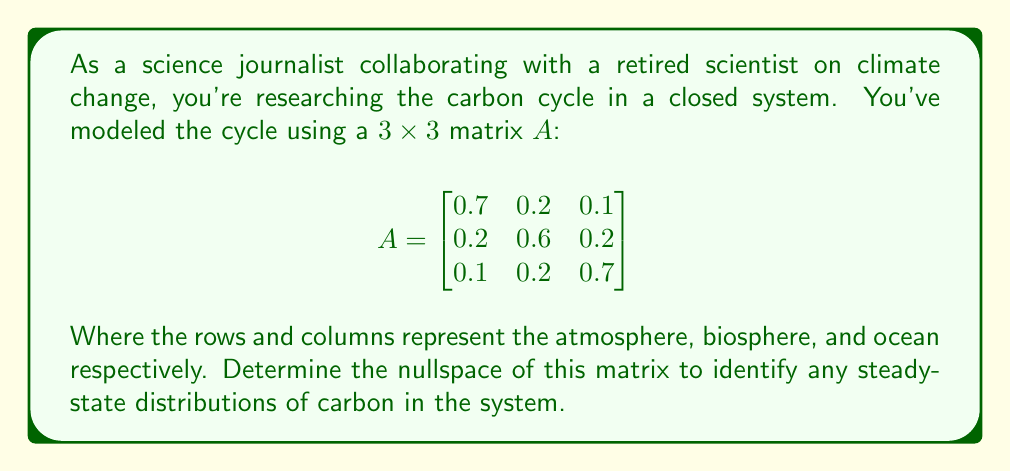Can you answer this question? To find the nullspace of matrix $A$, we need to solve the equation $A\vec{x} = \vec{0}$, where $\vec{x}$ is a non-zero vector.

1) First, we set up the equation:

   $$\begin{bmatrix}
   0.7 & 0.2 & 0.1 \\
   0.2 & 0.6 & 0.2 \\
   0.1 & 0.2 & 0.7
   \end{bmatrix} \begin{bmatrix} x \\ y \\ z \end{bmatrix} = \begin{bmatrix} 0 \\ 0 \\ 0 \end{bmatrix}$$

2) This gives us a system of equations:

   $$\begin{cases}
   0.7x + 0.2y + 0.1z = 0 \\
   0.2x + 0.6y + 0.2z = 0 \\
   0.1x + 0.2y + 0.7z = 0
   \end{cases}$$

3) To solve this, we can use Gaussian elimination. The augmented matrix is:

   $$\begin{bmatrix}
   0.7 & 0.2 & 0.1 & 0 \\
   0.2 & 0.6 & 0.2 & 0 \\
   0.1 & 0.2 & 0.7 & 0
   \end{bmatrix}$$

4) After row operations, we get:

   $$\begin{bmatrix}
   1 & 0 & 0 & 0 \\
   0 & 1 & 0 & 0 \\
   0 & 0 & 1 & 0
   \end{bmatrix}$$

5) This reduced row echelon form shows that the only solution is the trivial solution $x = y = z = 0$.

6) Therefore, the nullspace of $A$ contains only the zero vector.

This result has a significant interpretation in the context of the carbon cycle. It means that there are no non-zero steady-state distributions of carbon in this closed system. In other words, any initial distribution of carbon will change over time according to the transition probabilities given in the matrix.
Answer: The nullspace of matrix $A$ is $\{\vec{0}\}$, containing only the zero vector. 